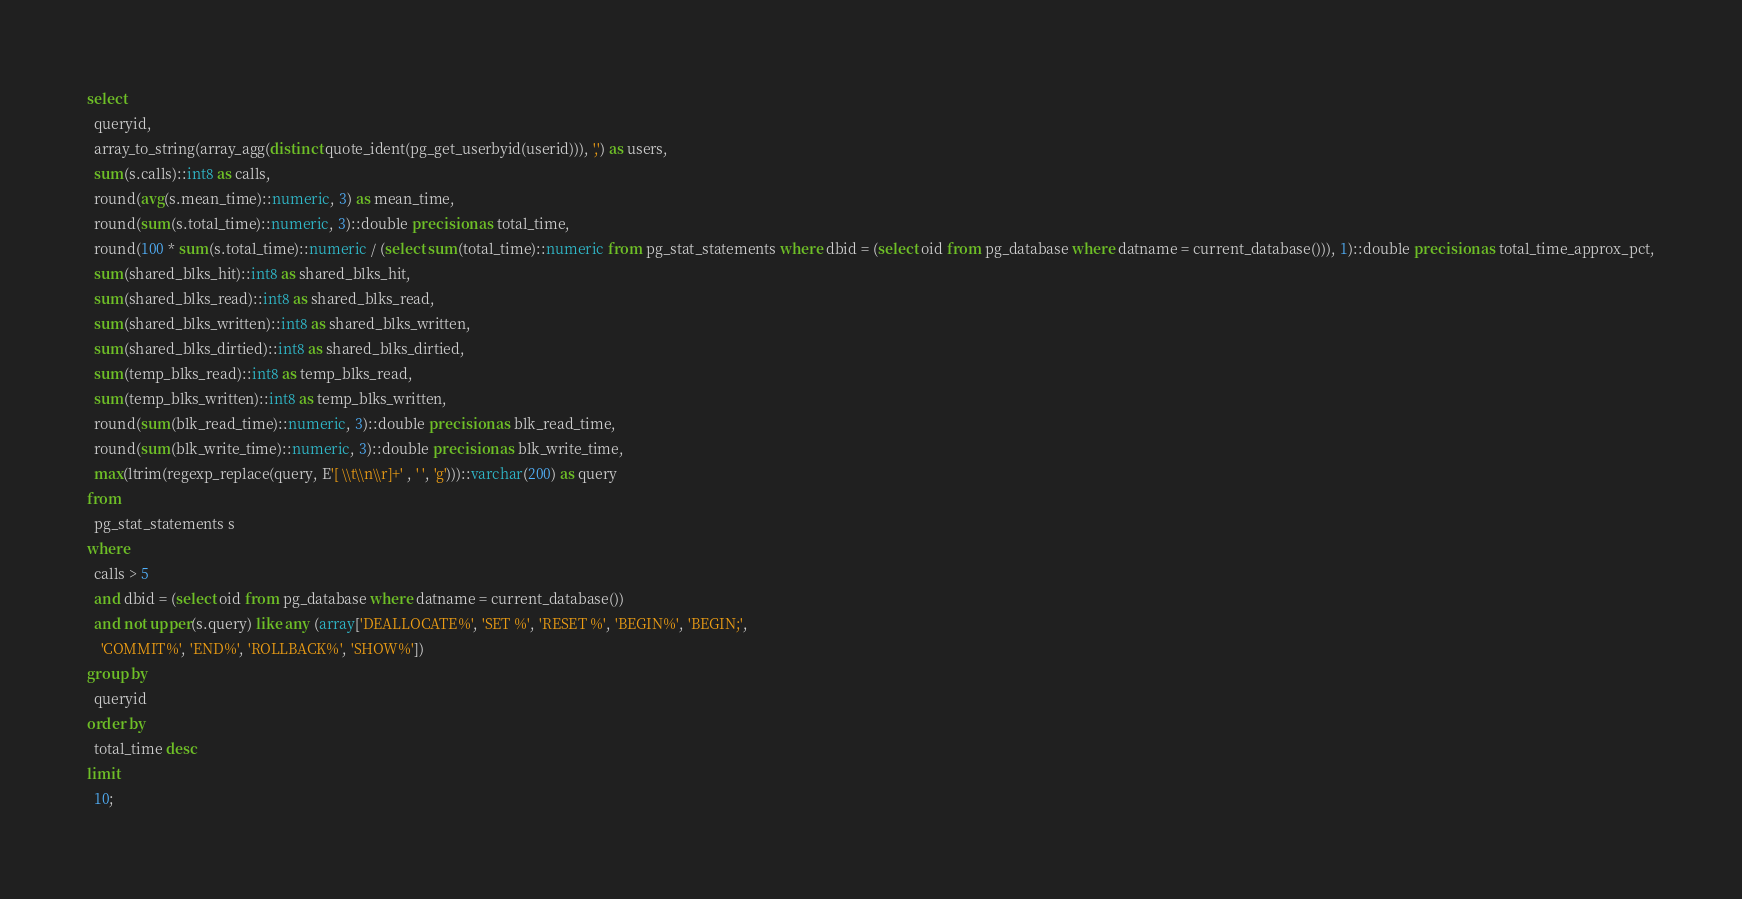<code> <loc_0><loc_0><loc_500><loc_500><_SQL_>select
  queryid,
  array_to_string(array_agg(distinct quote_ident(pg_get_userbyid(userid))), ',') as users,
  sum(s.calls)::int8 as calls,
  round(avg(s.mean_time)::numeric, 3) as mean_time,
  round(sum(s.total_time)::numeric, 3)::double precision as total_time,
  round(100 * sum(s.total_time)::numeric / (select sum(total_time)::numeric from pg_stat_statements where dbid = (select oid from pg_database where datname = current_database())), 1)::double precision as total_time_approx_pct,
  sum(shared_blks_hit)::int8 as shared_blks_hit,
  sum(shared_blks_read)::int8 as shared_blks_read,
  sum(shared_blks_written)::int8 as shared_blks_written,
  sum(shared_blks_dirtied)::int8 as shared_blks_dirtied,
  sum(temp_blks_read)::int8 as temp_blks_read,
  sum(temp_blks_written)::int8 as temp_blks_written,
  round(sum(blk_read_time)::numeric, 3)::double precision as blk_read_time,
  round(sum(blk_write_time)::numeric, 3)::double precision as blk_write_time,
  max(ltrim(regexp_replace(query, E'[ \\t\\n\\r]+' , ' ', 'g')))::varchar(200) as query
from
  pg_stat_statements s
where
  calls > 5
  and dbid = (select oid from pg_database where datname = current_database())
  and not upper(s.query) like any (array['DEALLOCATE%', 'SET %', 'RESET %', 'BEGIN%', 'BEGIN;',
    'COMMIT%', 'END%', 'ROLLBACK%', 'SHOW%'])
group by
  queryid
order by
  total_time desc
limit
  10;
</code> 